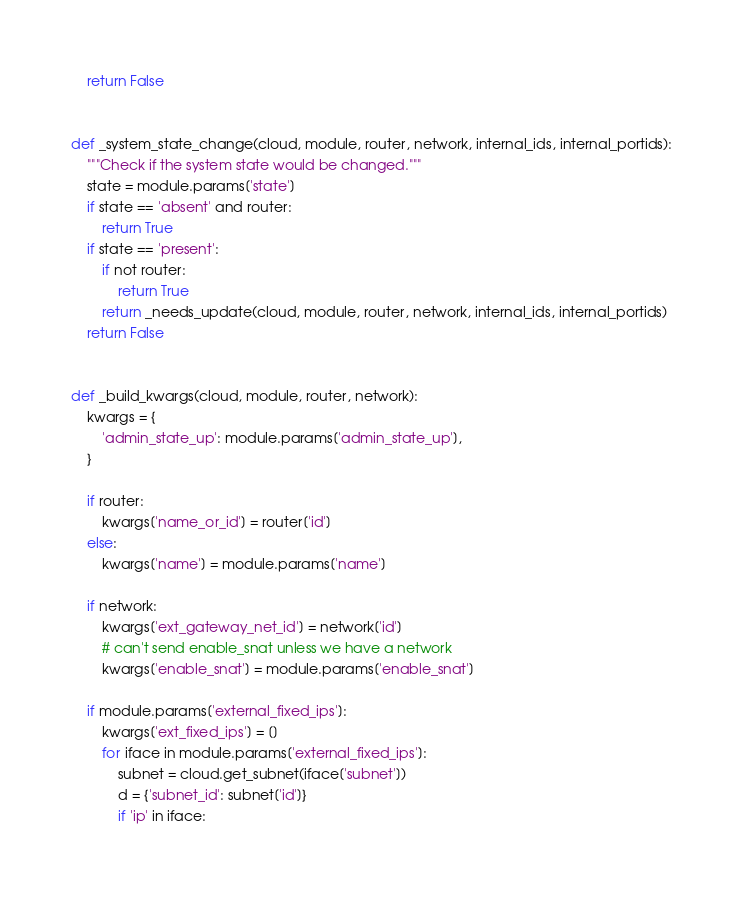<code> <loc_0><loc_0><loc_500><loc_500><_Python_>
    return False


def _system_state_change(cloud, module, router, network, internal_ids, internal_portids):
    """Check if the system state would be changed."""
    state = module.params['state']
    if state == 'absent' and router:
        return True
    if state == 'present':
        if not router:
            return True
        return _needs_update(cloud, module, router, network, internal_ids, internal_portids)
    return False


def _build_kwargs(cloud, module, router, network):
    kwargs = {
        'admin_state_up': module.params['admin_state_up'],
    }

    if router:
        kwargs['name_or_id'] = router['id']
    else:
        kwargs['name'] = module.params['name']

    if network:
        kwargs['ext_gateway_net_id'] = network['id']
        # can't send enable_snat unless we have a network
        kwargs['enable_snat'] = module.params['enable_snat']

    if module.params['external_fixed_ips']:
        kwargs['ext_fixed_ips'] = []
        for iface in module.params['external_fixed_ips']:
            subnet = cloud.get_subnet(iface['subnet'])
            d = {'subnet_id': subnet['id']}
            if 'ip' in iface:</code> 